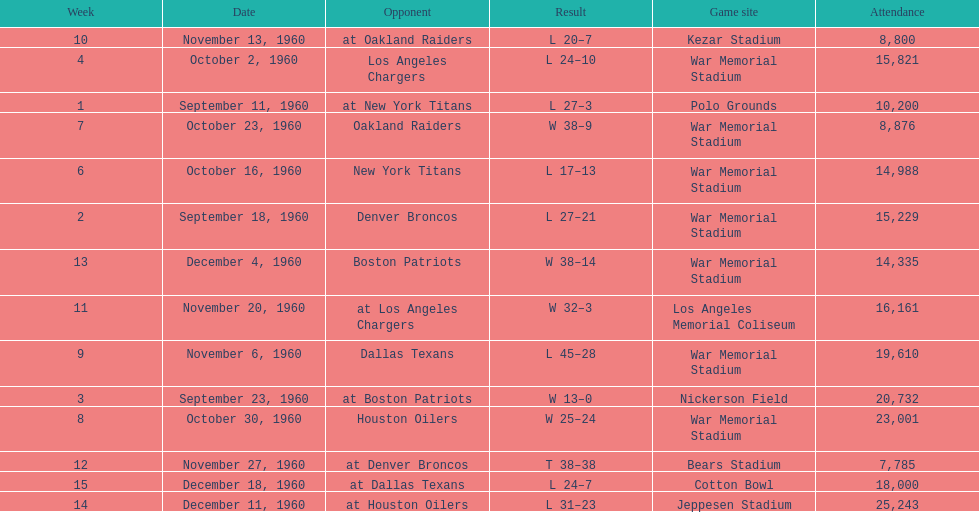How many games had at least 10,000 people in attendance? 11. 